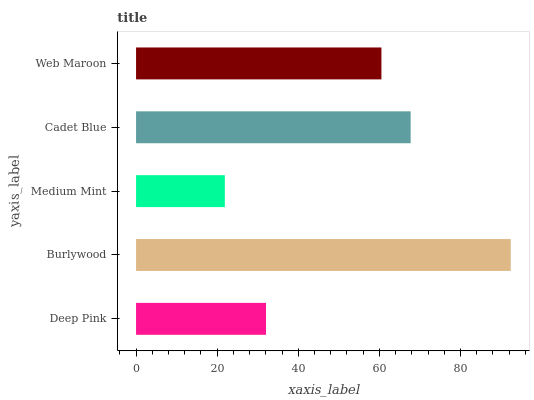Is Medium Mint the minimum?
Answer yes or no. Yes. Is Burlywood the maximum?
Answer yes or no. Yes. Is Burlywood the minimum?
Answer yes or no. No. Is Medium Mint the maximum?
Answer yes or no. No. Is Burlywood greater than Medium Mint?
Answer yes or no. Yes. Is Medium Mint less than Burlywood?
Answer yes or no. Yes. Is Medium Mint greater than Burlywood?
Answer yes or no. No. Is Burlywood less than Medium Mint?
Answer yes or no. No. Is Web Maroon the high median?
Answer yes or no. Yes. Is Web Maroon the low median?
Answer yes or no. Yes. Is Burlywood the high median?
Answer yes or no. No. Is Cadet Blue the low median?
Answer yes or no. No. 